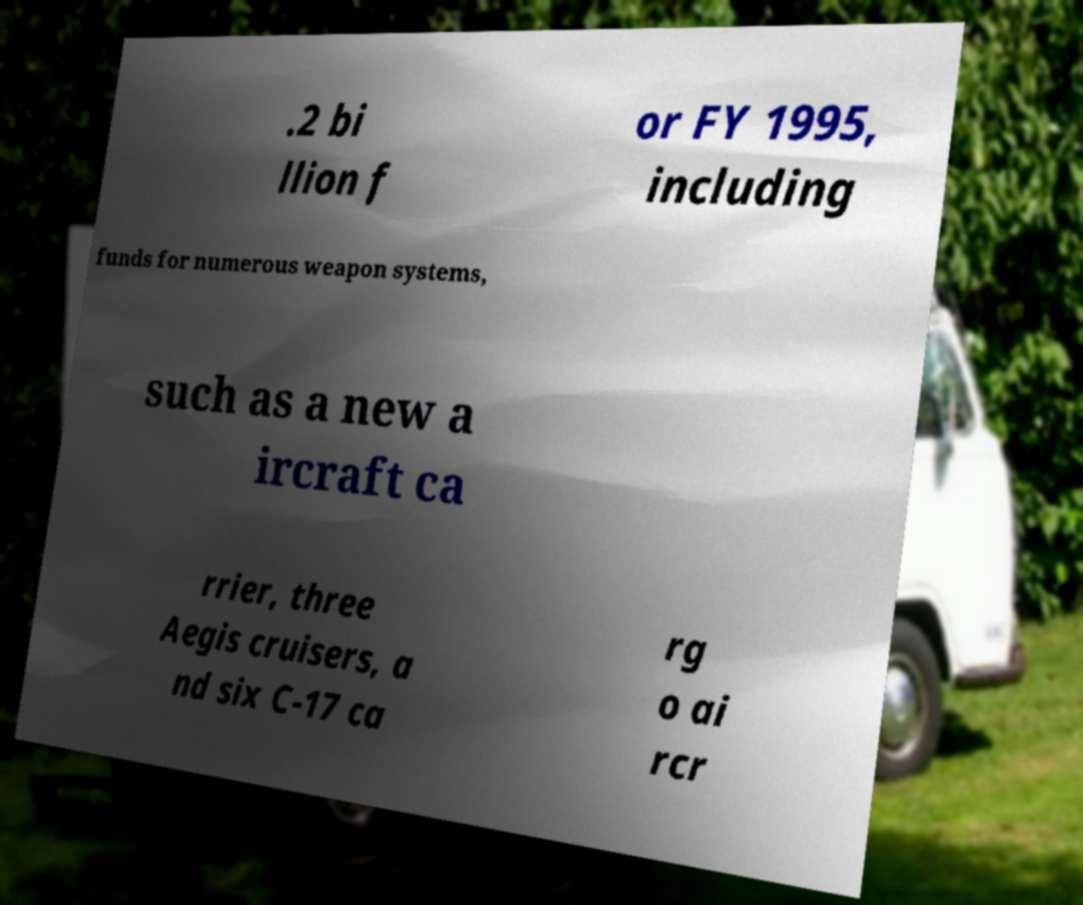Please read and relay the text visible in this image. What does it say? .2 bi llion f or FY 1995, including funds for numerous weapon systems, such as a new a ircraft ca rrier, three Aegis cruisers, a nd six C-17 ca rg o ai rcr 